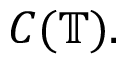Convert formula to latex. <formula><loc_0><loc_0><loc_500><loc_500>C ( \mathbb { T } ) .</formula> 